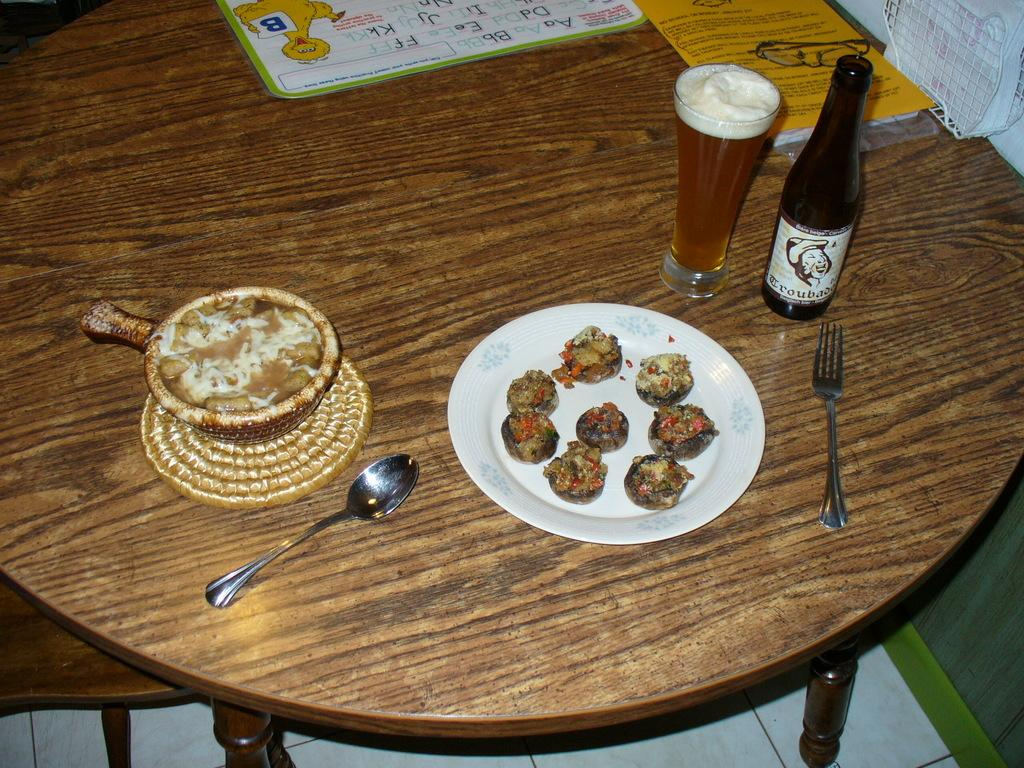What type of objects can be seen in the image related to eating or drinking? There are food items, spoons, a bottle, and a glass with liquid in the image. What else is present on the table in the image? There are papers on the table in the image. What type of yak can be seen using the apparatus in the image? There is no yak or apparatus present in the image. Can you tell me what the grandfather is doing in the image? There is no grandfather present in the image. 